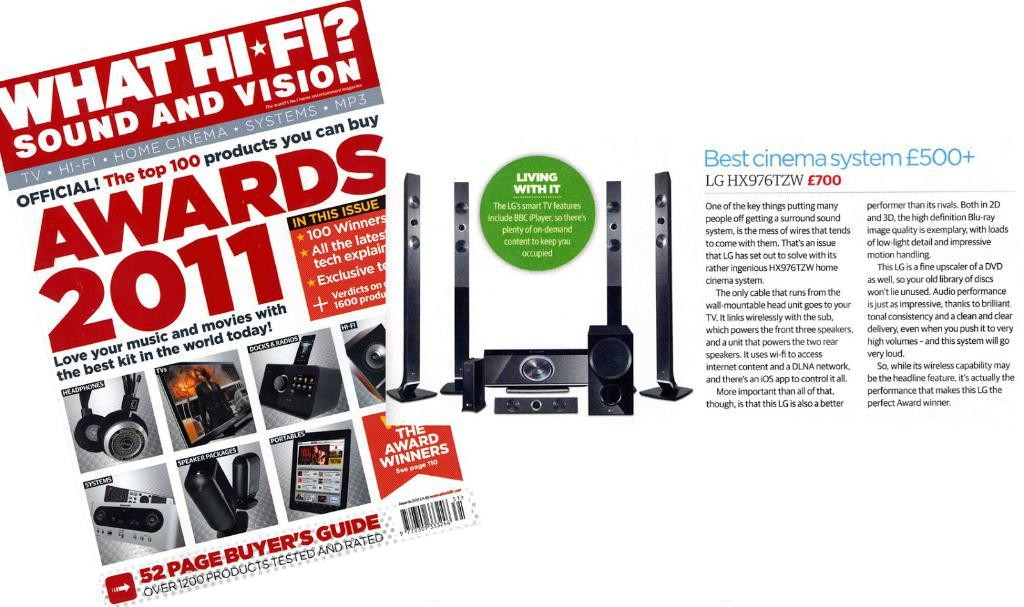<image>
Render a clear and concise summary of the photo. front of 52 page buyers guide of sound and vision products and an ad for lghx976tzw sound system 